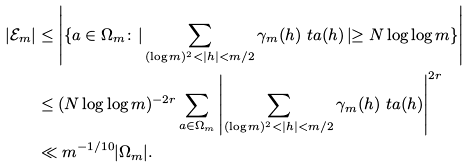<formula> <loc_0><loc_0><loc_500><loc_500>| \mathcal { E } _ { m } | & \leq \left | \left \{ a \in \Omega _ { m } \colon \right | \sum _ { ( \log m ) ^ { 2 } < | h | < m / 2 } \gamma _ { m } ( h ) \ t a ( h ) \left | \geq N \log \log m \right \} \right | \\ & \leq ( N \log \log m ) ^ { - 2 r } \sum _ { a \in \Omega _ { m } } \left | \sum _ { ( \log m ) ^ { 2 } < | h | < m / 2 } \gamma _ { m } ( h ) \ t a ( h ) \right | ^ { 2 r } \\ & \ll m ^ { - 1 / 1 0 } | \Omega _ { m } | .</formula> 